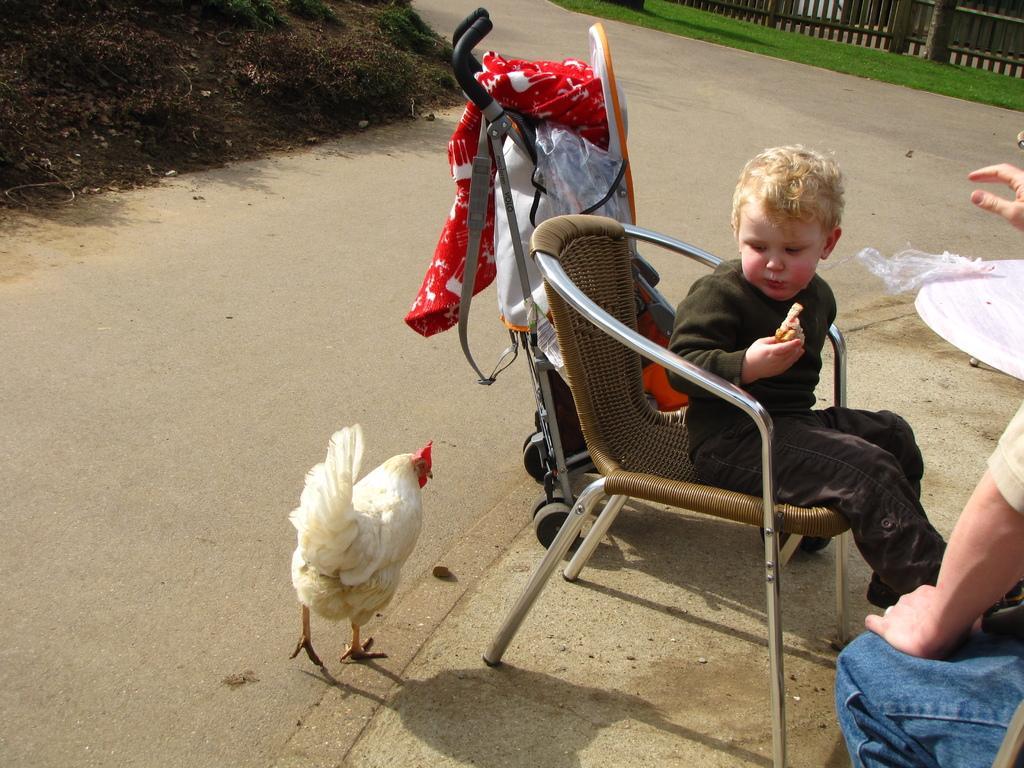Can you describe this image briefly? This is a boy holding some food item and sitting on the chair. This looks like a stroller. I can see a hen walking on the road. I think this is the table. At the right side of the image, I can see a person sitting. This looks like a wooden fence. Here is the grass. 